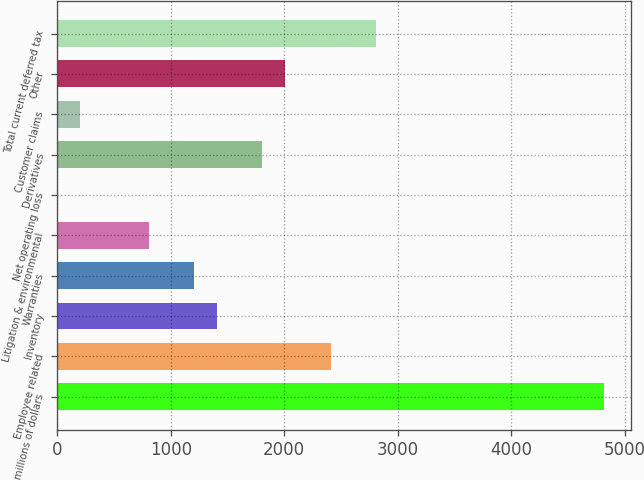<chart> <loc_0><loc_0><loc_500><loc_500><bar_chart><fcel>millions of dollars<fcel>Employee related<fcel>Inventory<fcel>Warranties<fcel>Litigation & environmental<fcel>Net operating loss<fcel>Derivatives<fcel>Customer claims<fcel>Other<fcel>Total current deferred tax<nl><fcel>4816.68<fcel>2409.24<fcel>1406.14<fcel>1205.52<fcel>804.28<fcel>1.8<fcel>1807.38<fcel>202.42<fcel>2008<fcel>2810.48<nl></chart> 